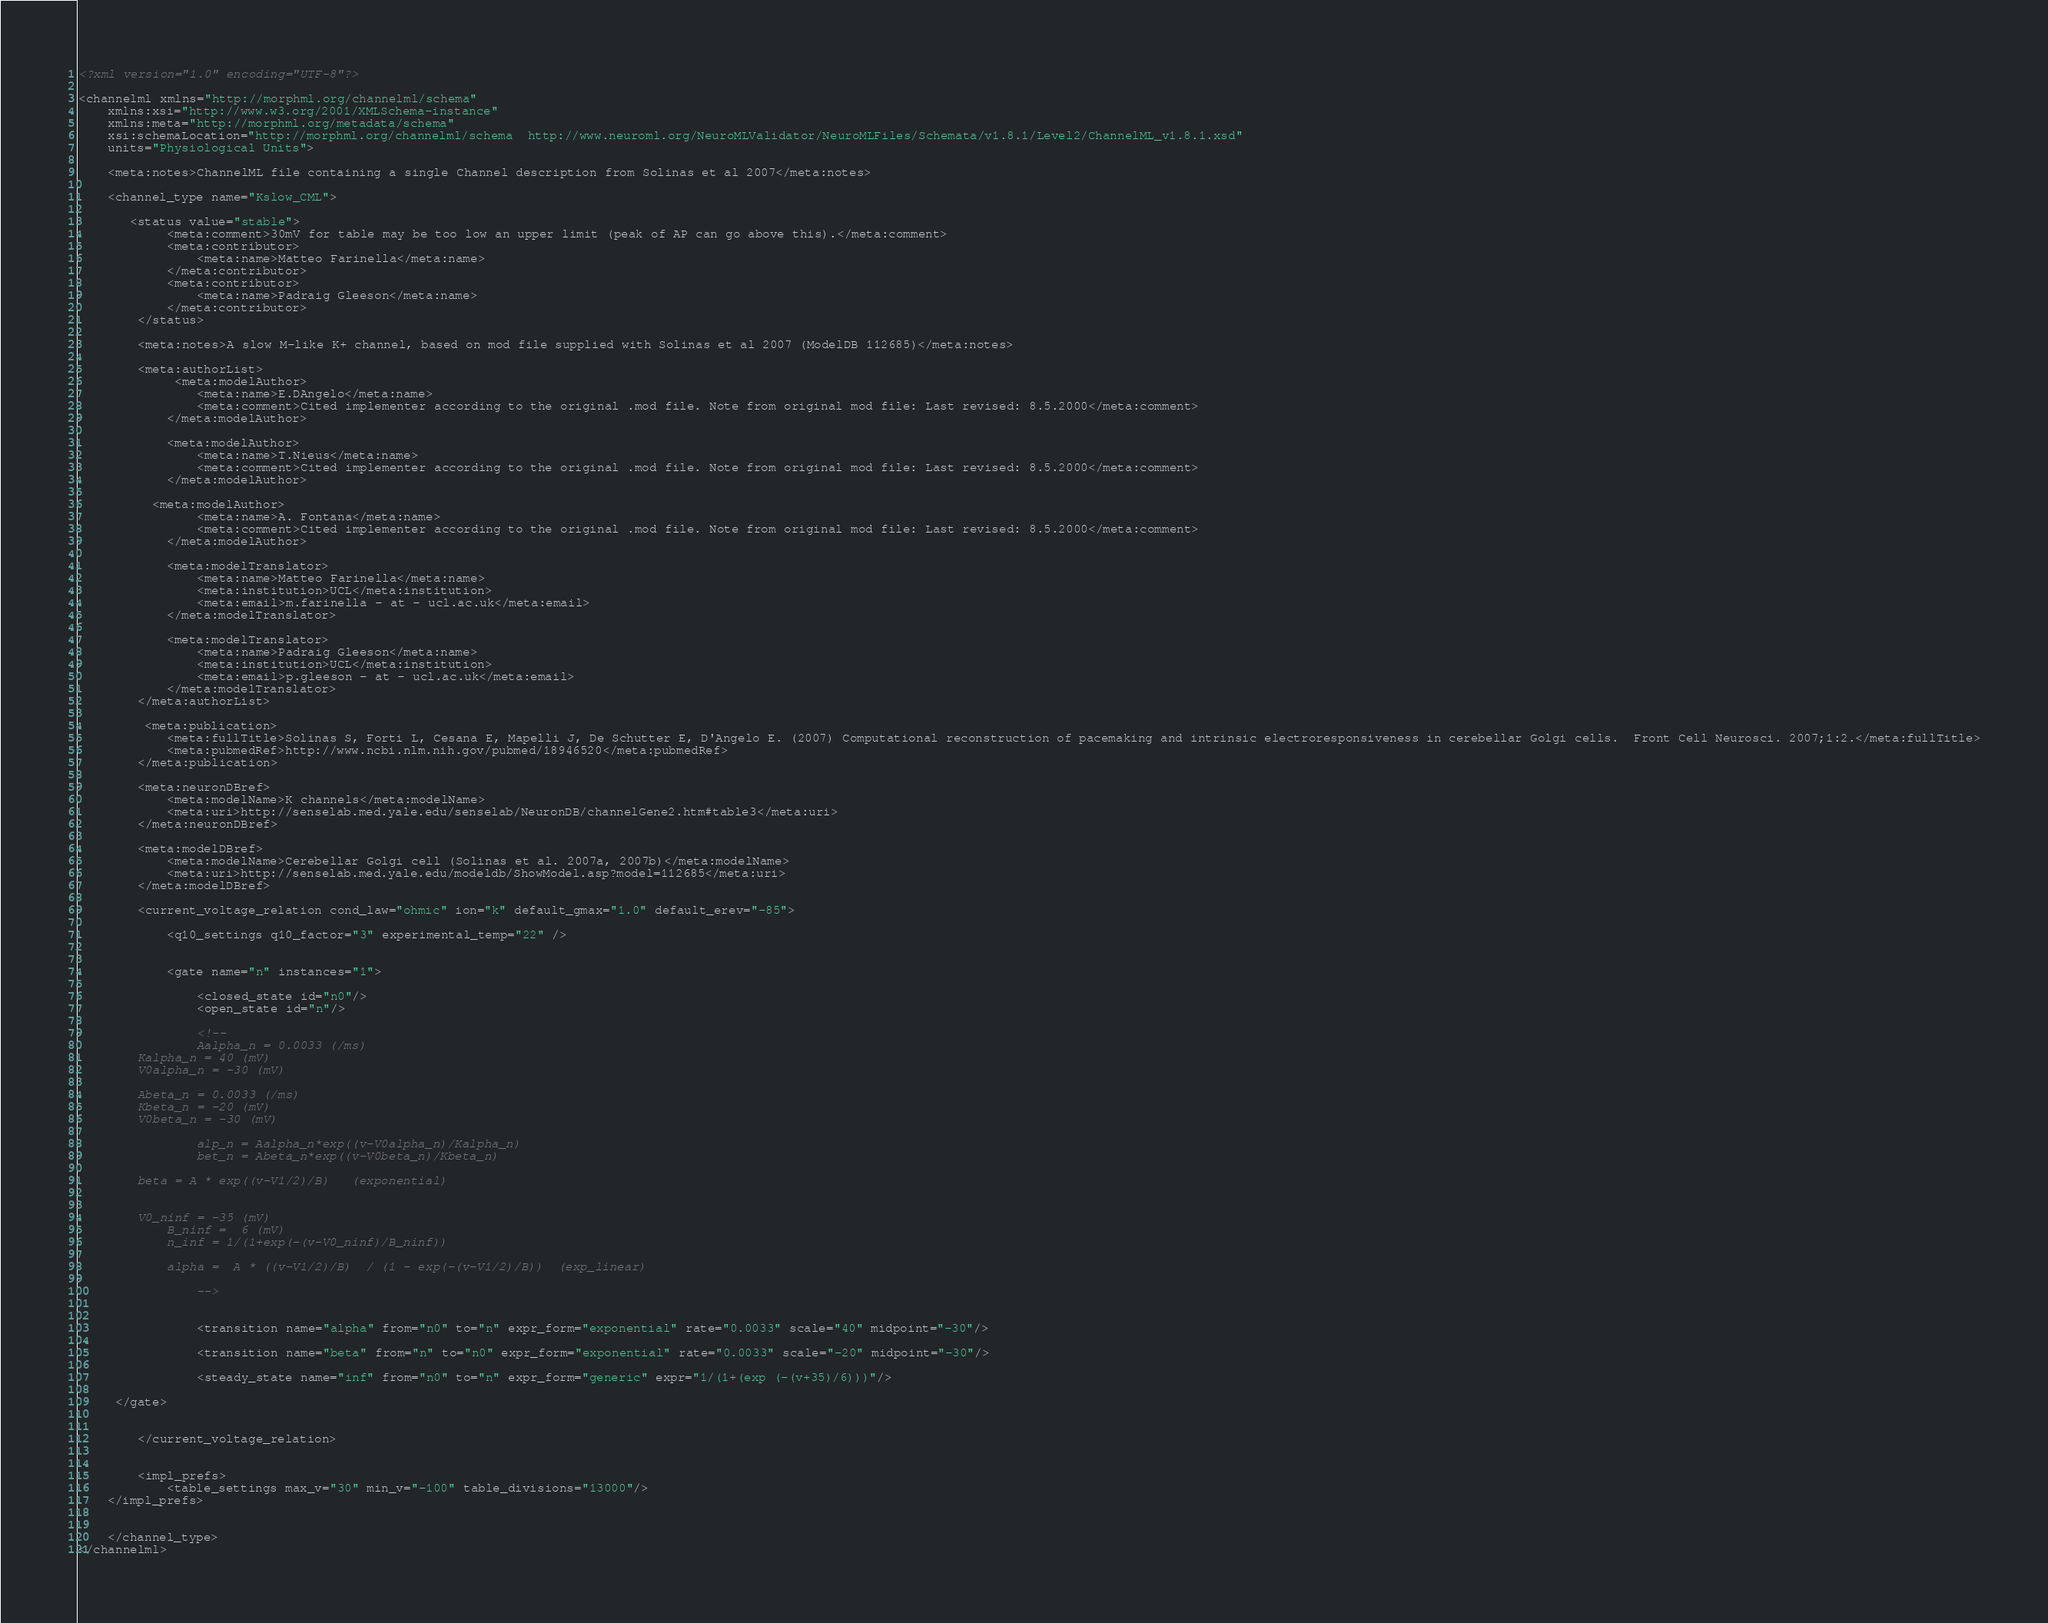Convert code to text. <code><loc_0><loc_0><loc_500><loc_500><_XML_><?xml version="1.0" encoding="UTF-8"?>

<channelml xmlns="http://morphml.org/channelml/schema"
    xmlns:xsi="http://www.w3.org/2001/XMLSchema-instance"
    xmlns:meta="http://morphml.org/metadata/schema"
    xsi:schemaLocation="http://morphml.org/channelml/schema  http://www.neuroml.org/NeuroMLValidator/NeuroMLFiles/Schemata/v1.8.1/Level2/ChannelML_v1.8.1.xsd"
    units="Physiological Units">
        
    <meta:notes>ChannelML file containing a single Channel description from Solinas et al 2007</meta:notes>
    
    <channel_type name="Kslow_CML">

       <status value="stable">
            <meta:comment>30mV for table may be too low an upper limit (peak of AP can go above this).</meta:comment>
            <meta:contributor>
                <meta:name>Matteo Farinella</meta:name>
            </meta:contributor>
            <meta:contributor>
                <meta:name>Padraig Gleeson</meta:name>
            </meta:contributor>
        </status>
        
        <meta:notes>A slow M-like K+ channel, based on mod file supplied with Solinas et al 2007 (ModelDB 112685)</meta:notes>

        <meta:authorList>
             <meta:modelAuthor>
                <meta:name>E.DAngelo</meta:name>
                <meta:comment>Cited implementer according to the original .mod file. Note from original mod file: Last revised: 8.5.2000</meta:comment>
            </meta:modelAuthor>

            <meta:modelAuthor>
                <meta:name>T.Nieus</meta:name>
                <meta:comment>Cited implementer according to the original .mod file. Note from original mod file: Last revised: 8.5.2000</meta:comment>
            </meta:modelAuthor>

          <meta:modelAuthor>
                <meta:name>A. Fontana</meta:name>
                <meta:comment>Cited implementer according to the original .mod file. Note from original mod file: Last revised: 8.5.2000</meta:comment>
            </meta:modelAuthor>

            <meta:modelTranslator>
                <meta:name>Matteo Farinella</meta:name>
                <meta:institution>UCL</meta:institution>
                <meta:email>m.farinella - at - ucl.ac.uk</meta:email>
            </meta:modelTranslator>

            <meta:modelTranslator>
                <meta:name>Padraig Gleeson</meta:name>
                <meta:institution>UCL</meta:institution>    
                <meta:email>p.gleeson - at - ucl.ac.uk</meta:email>
            </meta:modelTranslator>
        </meta:authorList>

         <meta:publication>
            <meta:fullTitle>Solinas S, Forti L, Cesana E, Mapelli J, De Schutter E, D'Angelo E. (2007) Computational reconstruction of pacemaking and intrinsic electroresponsiveness in cerebellar Golgi cells.  Front Cell Neurosci. 2007;1:2.</meta:fullTitle>
            <meta:pubmedRef>http://www.ncbi.nlm.nih.gov/pubmed/18946520</meta:pubmedRef>
        </meta:publication>

        <meta:neuronDBref>
            <meta:modelName>K channels</meta:modelName>
            <meta:uri>http://senselab.med.yale.edu/senselab/NeuronDB/channelGene2.htm#table3</meta:uri>
        </meta:neuronDBref>

        <meta:modelDBref>
            <meta:modelName>Cerebellar Golgi cell (Solinas et al. 2007a, 2007b)</meta:modelName>
            <meta:uri>http://senselab.med.yale.edu/modeldb/ShowModel.asp?model=112685</meta:uri>
        </meta:modelDBref>
        
        <current_voltage_relation cond_law="ohmic" ion="k" default_gmax="1.0" default_erev="-85">
            
            <q10_settings q10_factor="3" experimental_temp="22" />
            
            
            <gate name="n" instances="1">
            
                <closed_state id="n0"/>
                <open_state id="n"/>
                
                <!--
                Aalpha_n = 0.0033 (/ms)
		Kalpha_n = 40 (mV)
		V0alpha_n = -30 (mV)

		Abeta_n = 0.0033 (/ms)
		Kbeta_n = -20 (mV)
		V0beta_n = -30 (mV)
	
                alp_n = Aalpha_n*exp((v-V0alpha_n)/Kalpha_n)
                bet_n = Abeta_n*exp((v-V0beta_n)/Kbeta_n) 
               
		beta = A * exp((v-V1/2)/B)   (exponential)   
		
		
		V0_ninf = -35 (mV)
	        B_ninf =  6 (mV)	        
	        n_inf = 1/(1+exp(-(v-V0_ninf)/B_ninf))
	        
	        alpha =  A * ((v-V1/2)/B)  / (1 - exp(-(v-V1/2)/B))  (exp_linear)
	        
                -->

                     
                <transition name="alpha" from="n0" to="n" expr_form="exponential" rate="0.0033" scale="40" midpoint="-30"/>
                            
                <transition name="beta" from="n" to="n0" expr_form="exponential" rate="0.0033" scale="-20" midpoint="-30"/>
                
                <steady_state name="inf" from="n0" to="n" expr_form="generic" expr="1/(1+(exp (-(v+35)/6)))"/>
                              
	 </gate>

        
        </current_voltage_relation>
        

        <impl_prefs>
		    <table_settings max_v="30" min_v="-100" table_divisions="13000"/>
	</impl_prefs>

        
    </channel_type>
</channelml></code> 